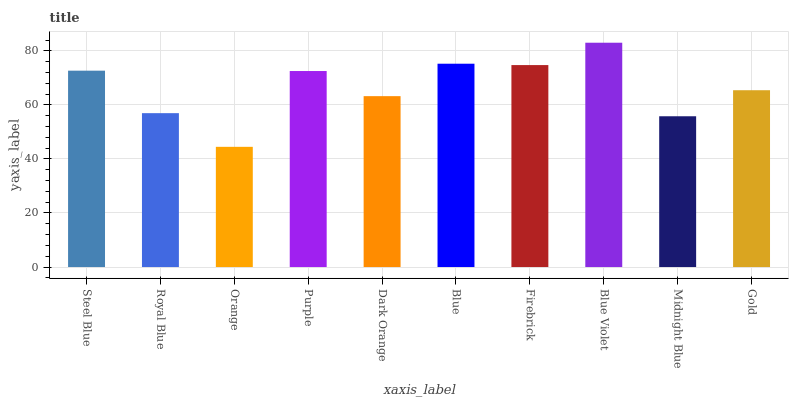Is Orange the minimum?
Answer yes or no. Yes. Is Blue Violet the maximum?
Answer yes or no. Yes. Is Royal Blue the minimum?
Answer yes or no. No. Is Royal Blue the maximum?
Answer yes or no. No. Is Steel Blue greater than Royal Blue?
Answer yes or no. Yes. Is Royal Blue less than Steel Blue?
Answer yes or no. Yes. Is Royal Blue greater than Steel Blue?
Answer yes or no. No. Is Steel Blue less than Royal Blue?
Answer yes or no. No. Is Purple the high median?
Answer yes or no. Yes. Is Gold the low median?
Answer yes or no. Yes. Is Blue the high median?
Answer yes or no. No. Is Purple the low median?
Answer yes or no. No. 